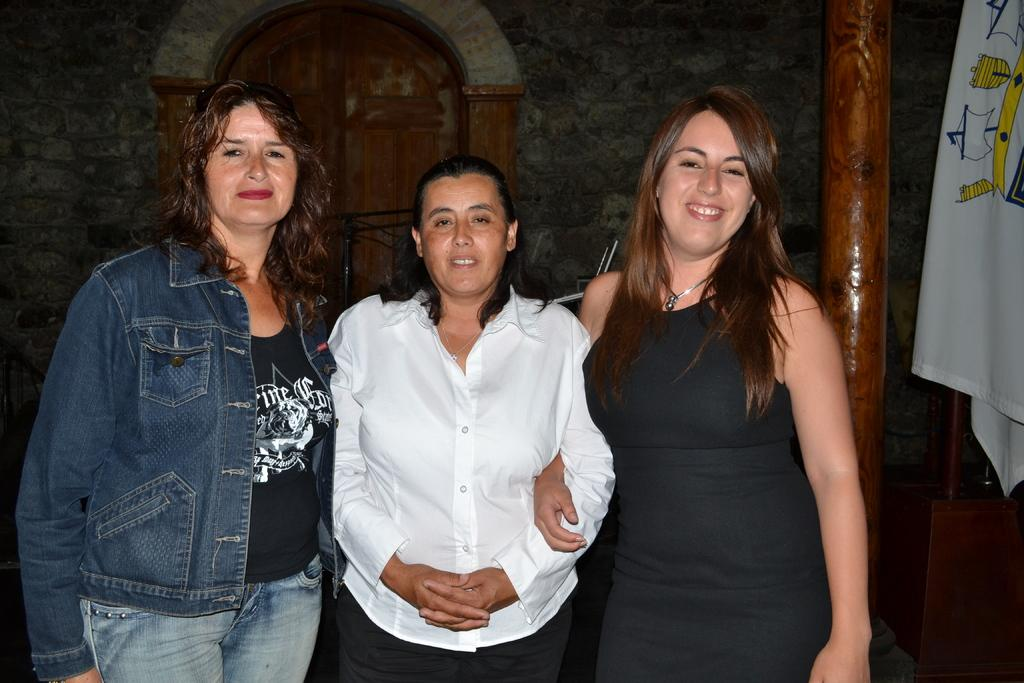Who are the main subjects in the image? There are ladies in the center of the image. What can be seen in the background of the image? There is a door in the background of the image. What architectural feature is present on the right side of the image? There is a pillar on the right side of the image. What type of rock did the ladies discover in the image? There is no rock present in the image, nor is there any indication of a discovery. 